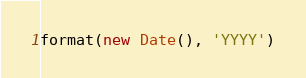Convert code to text. <code><loc_0><loc_0><loc_500><loc_500><_JavaScript_>format(new Date(), 'YYYY')

</code> 